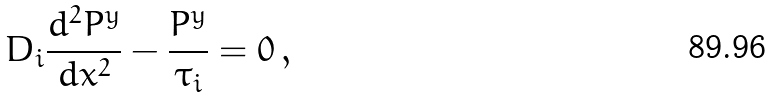<formula> <loc_0><loc_0><loc_500><loc_500>D _ { i } \frac { d ^ { 2 } P ^ { y } } { d x ^ { 2 } } - \frac { P ^ { y } } { \tau _ { i } } = 0 \, ,</formula> 